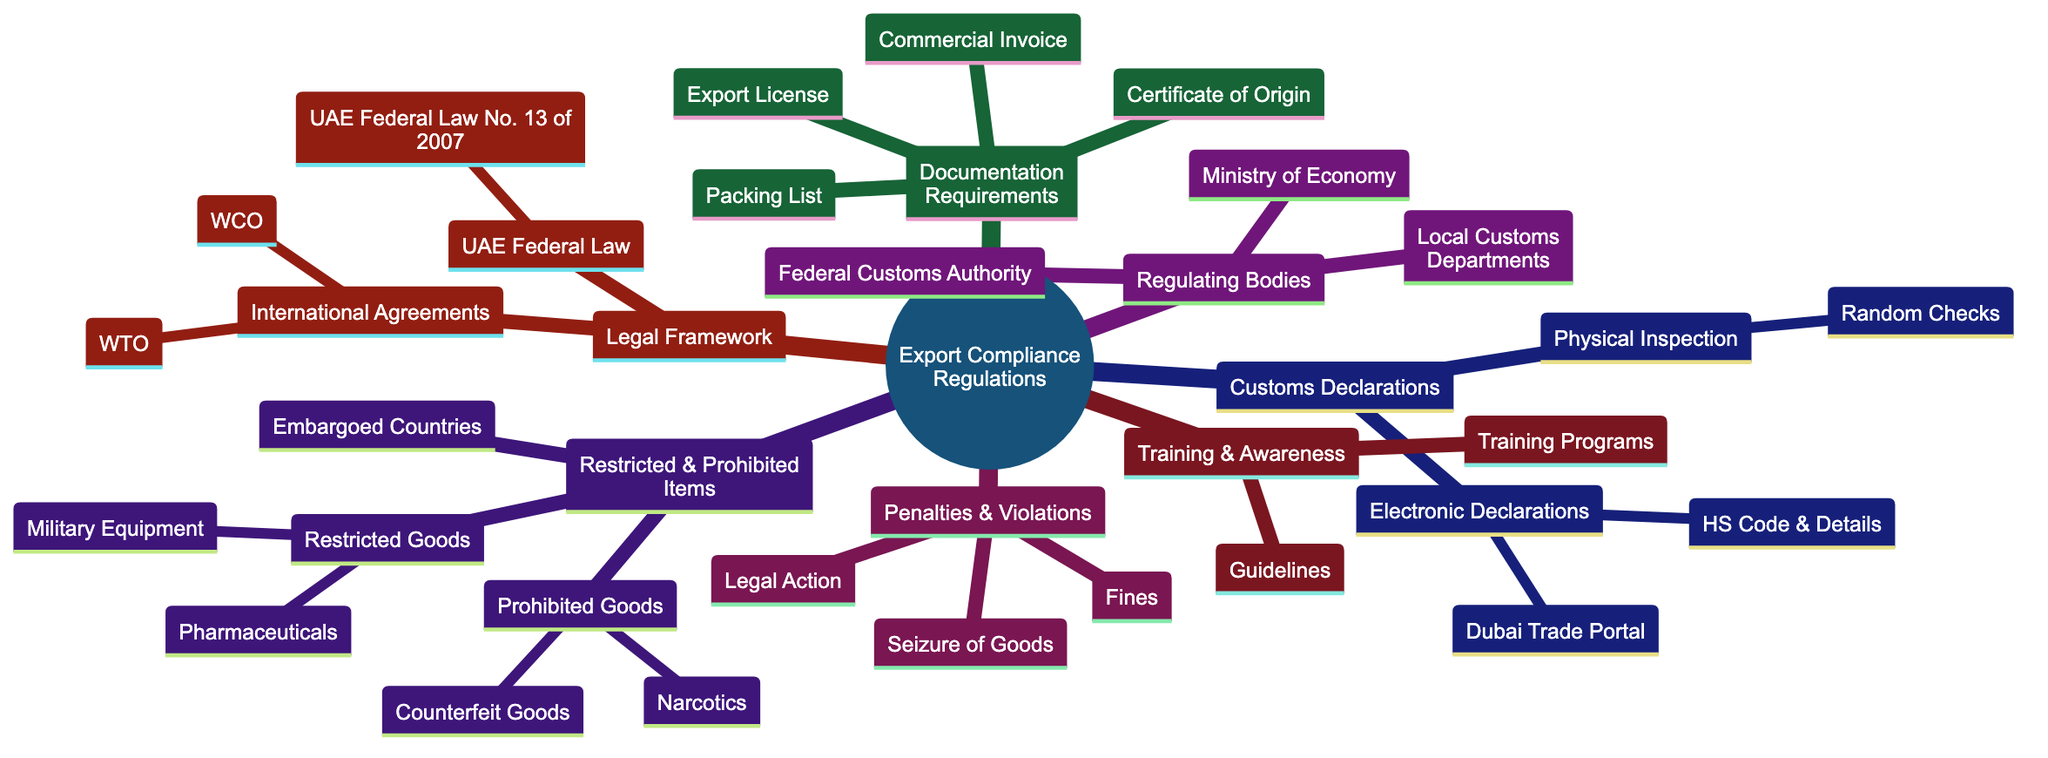What is the UAE Federal Law related to export compliance? The diagram indicates that the UAE Federal Law relevant to export compliance is No. 13 of 2007. This information is located under the "Legal Framework" section.
Answer: UAE Federal Law No. 13 of 2007 Which system is used for electronic customs declarations? The diagram lists the "Dubai Trade Portal" as the system for electronic declarations under the "Customs Declarations" section, specifically within the "Electronic Declarations" node.
Answer: Dubai Trade Portal How many types of documentation requirements are listed? By counting the items listed under "Documentation Requirements," there are four types: Commercial Invoice, Certificate of Origin, Packing List, and Export License.
Answer: 4 What are considered prohibited goods? The diagram specifies "Narcotics" and "Counterfeit Goods" under the "Prohibited Goods" section, indicating what items fall under this category.
Answer: Narcotics, Counterfeit Goods What is the primary regulatory body for customs? The diagram identifies the "Federal Customs Authority" as the primary regulatory body for customs in the "Regulating Bodies" section.
Answer: Federal Customs Authority What actions can be taken against non-compliance? According to the "Penalties & Violations" section, actions include fines, seizure of goods, and legal action, showing the possible penalties for non-compliance.
Answer: Fines, Seizure of Goods, Legal Action Which countries are impacted by trade sanctions? The diagram mentions "Embargoed Countries" as a category under "Restricted & Prohibited Items," indicating that this refers to countries listed under trade sanctions imposed by the UAE.
Answer: Embargoed Countries What are the training programs focused on? The "Training & Awareness" section of the diagram lists "Workshops and seminars on compliance" as part of the training initiatives available to enhance understanding of export compliance regulations.
Answer: Workshops and seminars on compliance Which two international agreements are mentioned? Under the "Legal Framework" section, the diagram lists "WTO – World Trade Organization" and "WCO – World Customs Organization" as the two international agreements.
Answer: WTO, WCO 